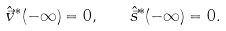<formula> <loc_0><loc_0><loc_500><loc_500>\hat { \vec { v } } ^ { * } ( - \infty ) = 0 , \quad \hat { \vec { s } } ^ { * } ( - \infty ) = 0 .</formula> 